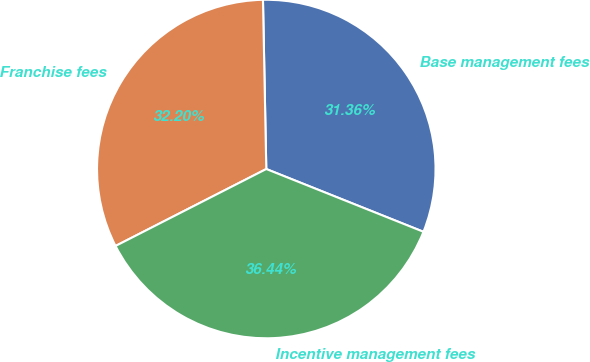<chart> <loc_0><loc_0><loc_500><loc_500><pie_chart><fcel>Base management fees<fcel>Franchise fees<fcel>Incentive management fees<nl><fcel>31.36%<fcel>32.2%<fcel>36.44%<nl></chart> 